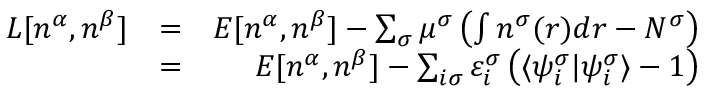<formula> <loc_0><loc_0><loc_500><loc_500>\begin{array} { r l r } { L [ n ^ { \alpha } , n ^ { \beta } ] } & { = } & { E [ n ^ { \alpha } , n ^ { \beta } ] - \sum _ { \sigma } \mu ^ { \sigma } \left ( \int n ^ { \sigma } ( r ) d r - N ^ { \sigma } \right ) } \\ & { = } & { E [ n ^ { \alpha } , n ^ { \beta } ] - \sum _ { i \sigma } \varepsilon _ { i } ^ { \sigma } \left ( \langle \psi _ { i } ^ { \sigma } | \psi _ { i } ^ { \sigma } \rangle - 1 \right ) } \end{array}</formula> 